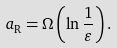<formula> <loc_0><loc_0><loc_500><loc_500>a _ { \text {R} } = \Omega \left ( \ln \frac { 1 } { \varepsilon } \right ) .</formula> 